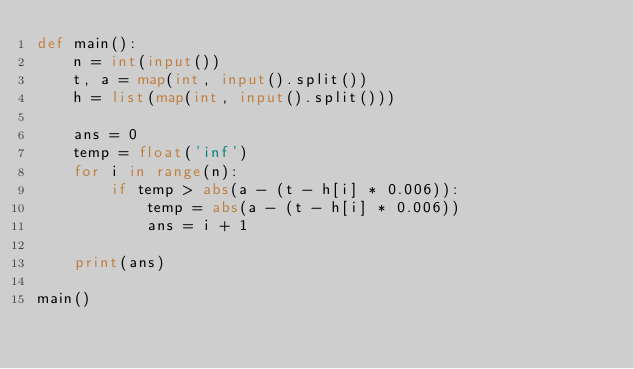<code> <loc_0><loc_0><loc_500><loc_500><_Python_>def main():
    n = int(input())
    t, a = map(int, input().split())
    h = list(map(int, input().split()))

    ans = 0
    temp = float('inf')
    for i in range(n):
        if temp > abs(a - (t - h[i] * 0.006)):
            temp = abs(a - (t - h[i] * 0.006))
            ans = i + 1
        
    print(ans)

main()
</code> 